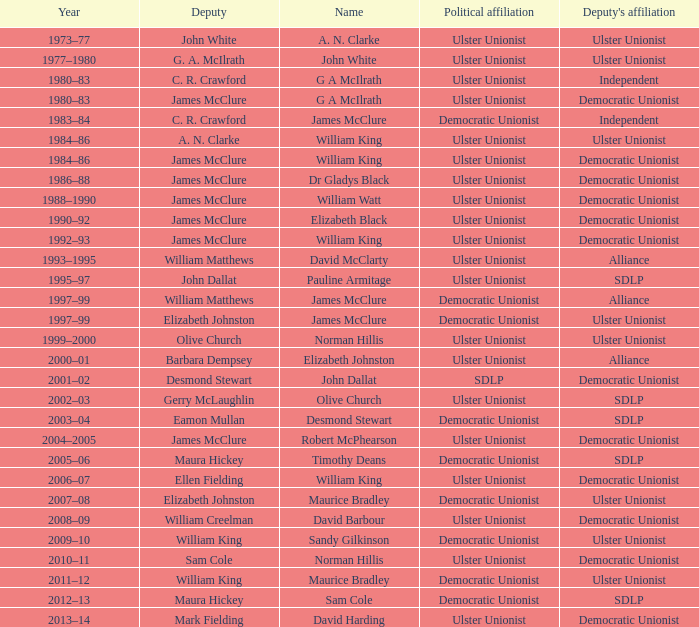What is the political connection of deputy john dallat? Ulster Unionist. 